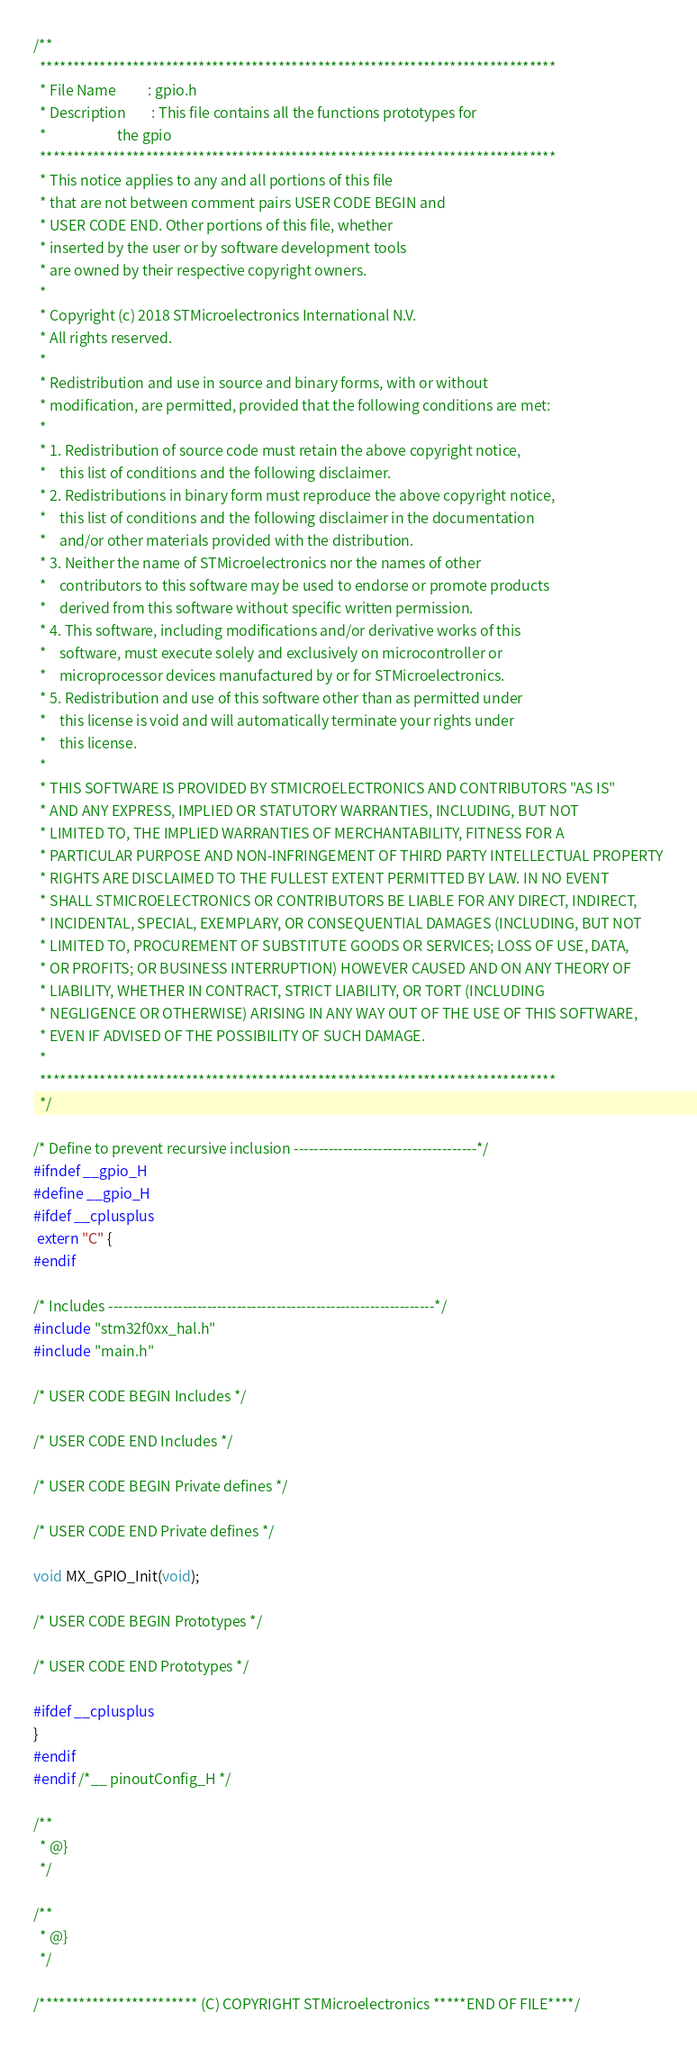Convert code to text. <code><loc_0><loc_0><loc_500><loc_500><_C_>/**
  ******************************************************************************
  * File Name          : gpio.h
  * Description        : This file contains all the functions prototypes for 
  *                      the gpio  
  ******************************************************************************
  * This notice applies to any and all portions of this file
  * that are not between comment pairs USER CODE BEGIN and
  * USER CODE END. Other portions of this file, whether 
  * inserted by the user or by software development tools
  * are owned by their respective copyright owners.
  *
  * Copyright (c) 2018 STMicroelectronics International N.V. 
  * All rights reserved.
  *
  * Redistribution and use in source and binary forms, with or without 
  * modification, are permitted, provided that the following conditions are met:
  *
  * 1. Redistribution of source code must retain the above copyright notice, 
  *    this list of conditions and the following disclaimer.
  * 2. Redistributions in binary form must reproduce the above copyright notice,
  *    this list of conditions and the following disclaimer in the documentation
  *    and/or other materials provided with the distribution.
  * 3. Neither the name of STMicroelectronics nor the names of other 
  *    contributors to this software may be used to endorse or promote products 
  *    derived from this software without specific written permission.
  * 4. This software, including modifications and/or derivative works of this 
  *    software, must execute solely and exclusively on microcontroller or
  *    microprocessor devices manufactured by or for STMicroelectronics.
  * 5. Redistribution and use of this software other than as permitted under 
  *    this license is void and will automatically terminate your rights under 
  *    this license. 
  *
  * THIS SOFTWARE IS PROVIDED BY STMICROELECTRONICS AND CONTRIBUTORS "AS IS" 
  * AND ANY EXPRESS, IMPLIED OR STATUTORY WARRANTIES, INCLUDING, BUT NOT 
  * LIMITED TO, THE IMPLIED WARRANTIES OF MERCHANTABILITY, FITNESS FOR A 
  * PARTICULAR PURPOSE AND NON-INFRINGEMENT OF THIRD PARTY INTELLECTUAL PROPERTY
  * RIGHTS ARE DISCLAIMED TO THE FULLEST EXTENT PERMITTED BY LAW. IN NO EVENT 
  * SHALL STMICROELECTRONICS OR CONTRIBUTORS BE LIABLE FOR ANY DIRECT, INDIRECT,
  * INCIDENTAL, SPECIAL, EXEMPLARY, OR CONSEQUENTIAL DAMAGES (INCLUDING, BUT NOT
  * LIMITED TO, PROCUREMENT OF SUBSTITUTE GOODS OR SERVICES; LOSS OF USE, DATA, 
  * OR PROFITS; OR BUSINESS INTERRUPTION) HOWEVER CAUSED AND ON ANY THEORY OF 
  * LIABILITY, WHETHER IN CONTRACT, STRICT LIABILITY, OR TORT (INCLUDING 
  * NEGLIGENCE OR OTHERWISE) ARISING IN ANY WAY OUT OF THE USE OF THIS SOFTWARE,
  * EVEN IF ADVISED OF THE POSSIBILITY OF SUCH DAMAGE.
  *
  ******************************************************************************
  */

/* Define to prevent recursive inclusion -------------------------------------*/
#ifndef __gpio_H
#define __gpio_H
#ifdef __cplusplus
 extern "C" {
#endif

/* Includes ------------------------------------------------------------------*/
#include "stm32f0xx_hal.h"
#include "main.h"

/* USER CODE BEGIN Includes */

/* USER CODE END Includes */

/* USER CODE BEGIN Private defines */

/* USER CODE END Private defines */

void MX_GPIO_Init(void);

/* USER CODE BEGIN Prototypes */

/* USER CODE END Prototypes */

#ifdef __cplusplus
}
#endif
#endif /*__ pinoutConfig_H */

/**
  * @}
  */

/**
  * @}
  */

/************************ (C) COPYRIGHT STMicroelectronics *****END OF FILE****/
</code> 